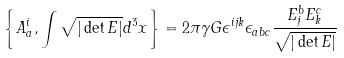Convert formula to latex. <formula><loc_0><loc_0><loc_500><loc_500>\left \{ A _ { a } ^ { i } , \int \sqrt { | \det E | } d ^ { 3 } x \right \} = 2 \pi \gamma G \epsilon ^ { i j k } \epsilon _ { a b c } \frac { E ^ { b } _ { j } E ^ { c } _ { k } } { \sqrt { | \det E | } }</formula> 